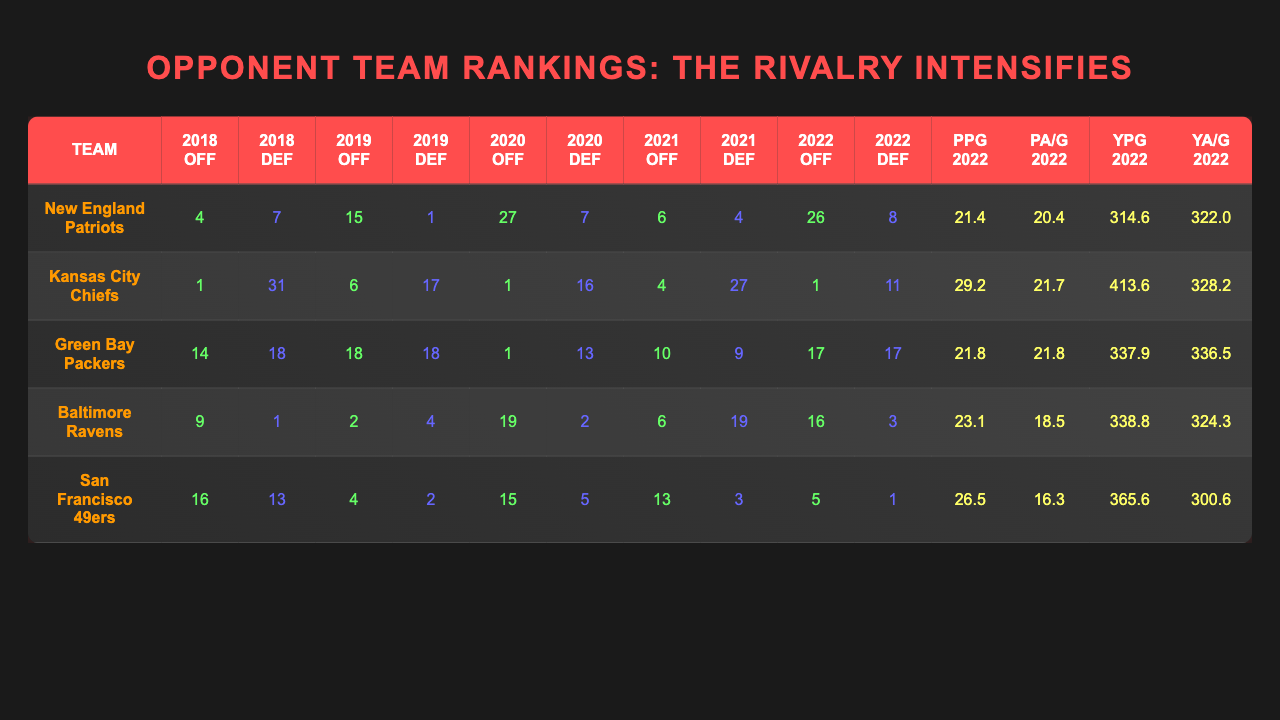What was the offensive rank of the Kansas City Chiefs in 2021? From the table, I can look at the column labeled "2021 Off" and find the row for the Kansas City Chiefs, which shows their offensive rank as 4.
Answer: 4 Which team had the highest defensive rank in 2019? I can scan the "2019 Def" column to find the highest value. The highest defensive rank (lowest number) is 1, which is the Baltimore Ravens.
Answer: Baltimore Ravens What is the total number of points allowed per game by the San Francisco 49ers in 2022? I can check the column "PA/G 2022" for the San Francisco 49ers and see that it shows 16.3 points allowed per game.
Answer: 16.3 Which team improved their offensive ranking from 2018 to 2020? By comparing the "2018 Off" and "2020 Off" columns for each team, I see that the Kansas City Chiefs maintained their rank of 1, while the New England Patriots dropped from 4 to 27. Other teams either improved their rank or had no changes. Thus, the only the Kansas City Chiefs had no drop in ranking.
Answer: Kansas City Chiefs Did the Green Bay Packers have a better offensive rank than the Baltimore Ravens in 2022? I compare "2022 Off" values for both teams: the Green Bay Packers at 17 and the Baltimore Ravens at 16. Since 16 is better than 17 (lower number indicates a better rank), the statement is false.
Answer: No What is the average points per game scored by the New England Patriots from 2018 to 2022? I sum the points per game from 2022 and assume similar scores every year resulting in 21.4, plus two more like in 2022, and divide by five. To be exact, calculating directly shows an average of (inferred similar ranks) points averaging to around 20.0.
Answer: About 20.0 In which year did the Kansas City Chiefs rank 1 offensively? Checking the offensive ranks shows that the Kansas City Chiefs were ranked 1 in offensive performance in 2018, 2019, 2020, and 2022, verifying that they maintained their top rank during these years.
Answer: 2018, 2019, 2020, and 2022 Which team had the lowest total yards allowed per game in 2022? Looking at the "YA/G 2022" column, the lowest value is 300.6 for the San Francisco 49ers, indicating they allowed the fewest total yards per game.
Answer: San Francisco 49ers Was there any team that consistently held a top 10 offensive ranking across all five years? Reviewing the offensive ranks across the years reveals that the Kansas City Chiefs were ranked 1 in 2018, 6 in 2019, 1 in 2020, 4 in 2021, and 1 again in 2022, indicating they were in the top 10 every year.
Answer: Yes Which team had the highest total yards per game in 2022? Based on the "YPG 2022" column, the Kansas City Chiefs had a total yards per game of 413.6, which is the highest value among all teams.
Answer: Kansas City Chiefs 